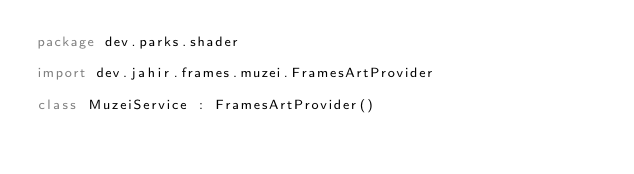<code> <loc_0><loc_0><loc_500><loc_500><_Kotlin_>package dev.parks.shader

import dev.jahir.frames.muzei.FramesArtProvider

class MuzeiService : FramesArtProvider()</code> 